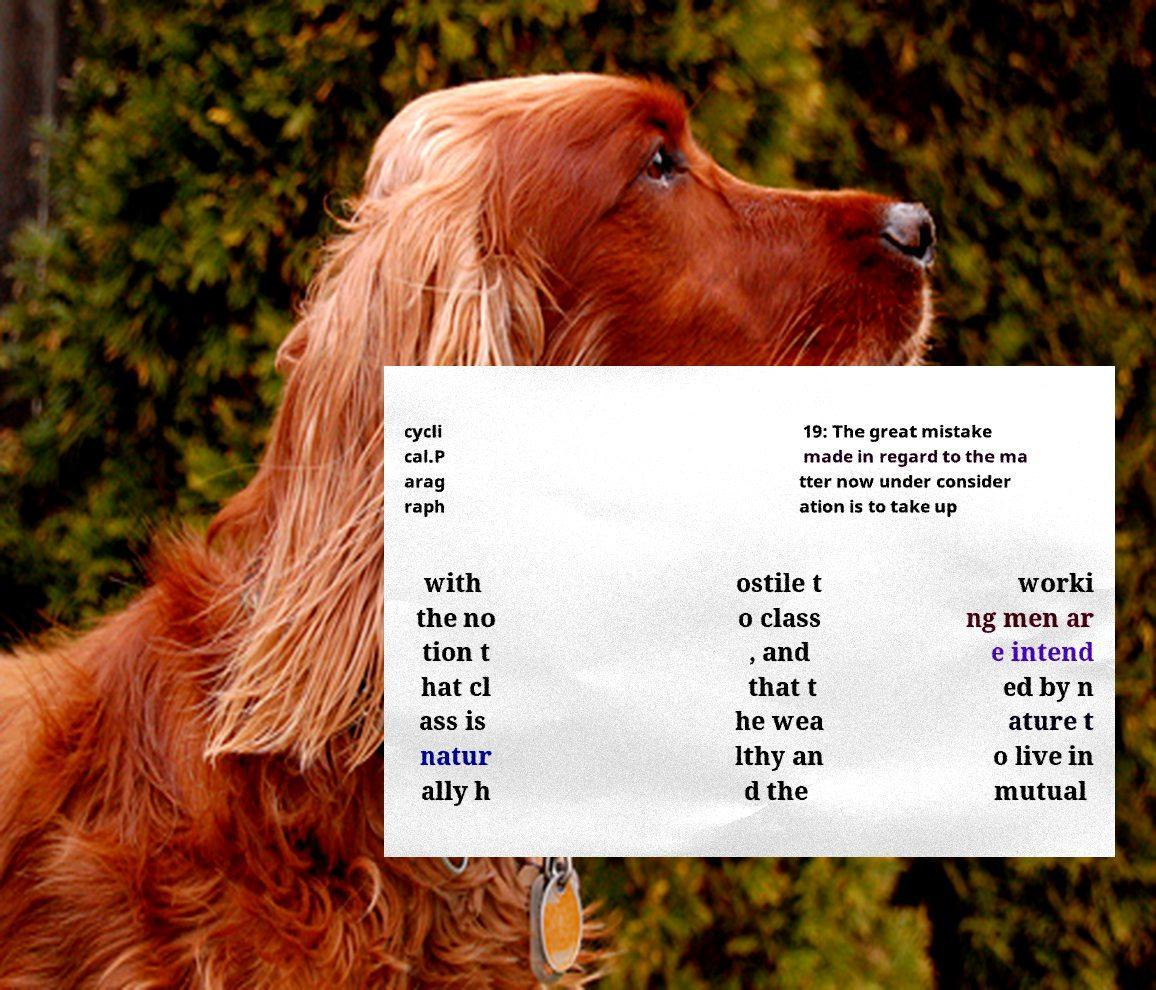There's text embedded in this image that I need extracted. Can you transcribe it verbatim? cycli cal.P arag raph 19: The great mistake made in regard to the ma tter now under consider ation is to take up with the no tion t hat cl ass is natur ally h ostile t o class , and that t he wea lthy an d the worki ng men ar e intend ed by n ature t o live in mutual 